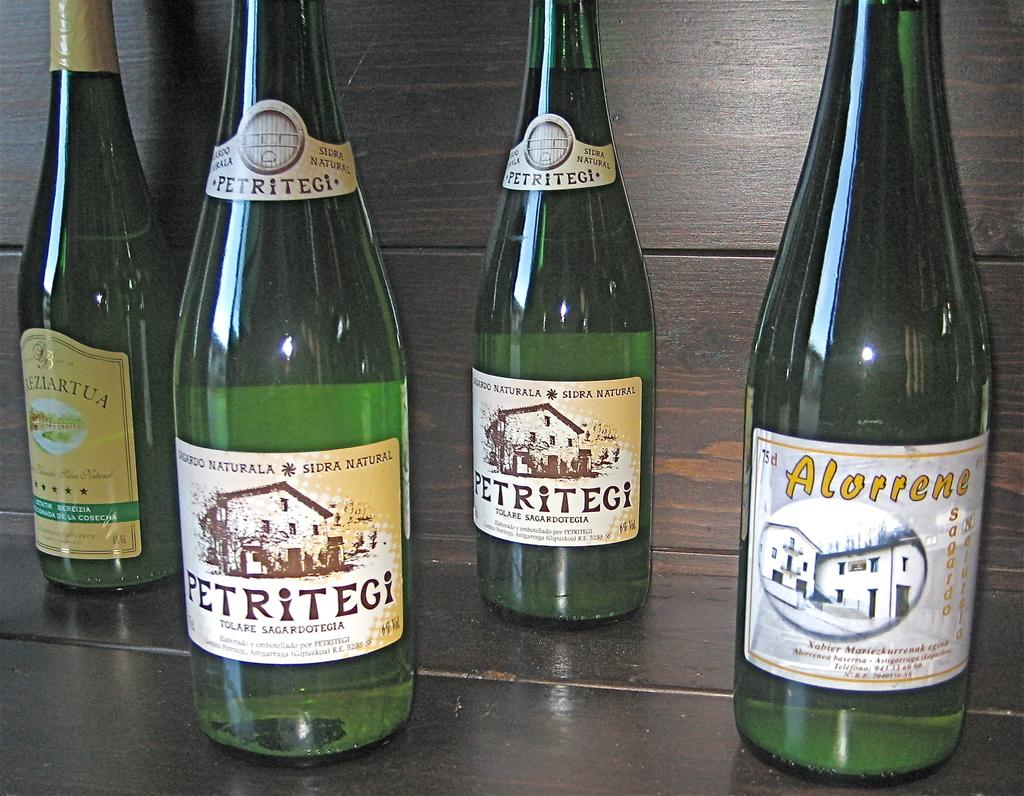Provide a one-sentence caption for the provided image. A group of four green wine bottles on a wood table. 